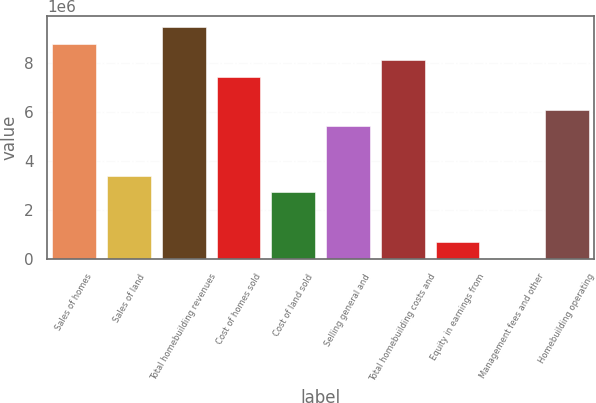Convert chart. <chart><loc_0><loc_0><loc_500><loc_500><bar_chart><fcel>Sales of homes<fcel>Sales of land<fcel>Total homebuilding revenues<fcel>Cost of homes sold<fcel>Cost of land sold<fcel>Selling general and<fcel>Total homebuilding costs and<fcel>Equity in earnings from<fcel>Management fees and other<fcel>Homebuilding operating<nl><fcel>8.7667e+06<fcel>3.39231e+06<fcel>9.4385e+06<fcel>7.4231e+06<fcel>2.72051e+06<fcel>5.4077e+06<fcel>8.0949e+06<fcel>705112<fcel>33313<fcel>6.0795e+06<nl></chart> 